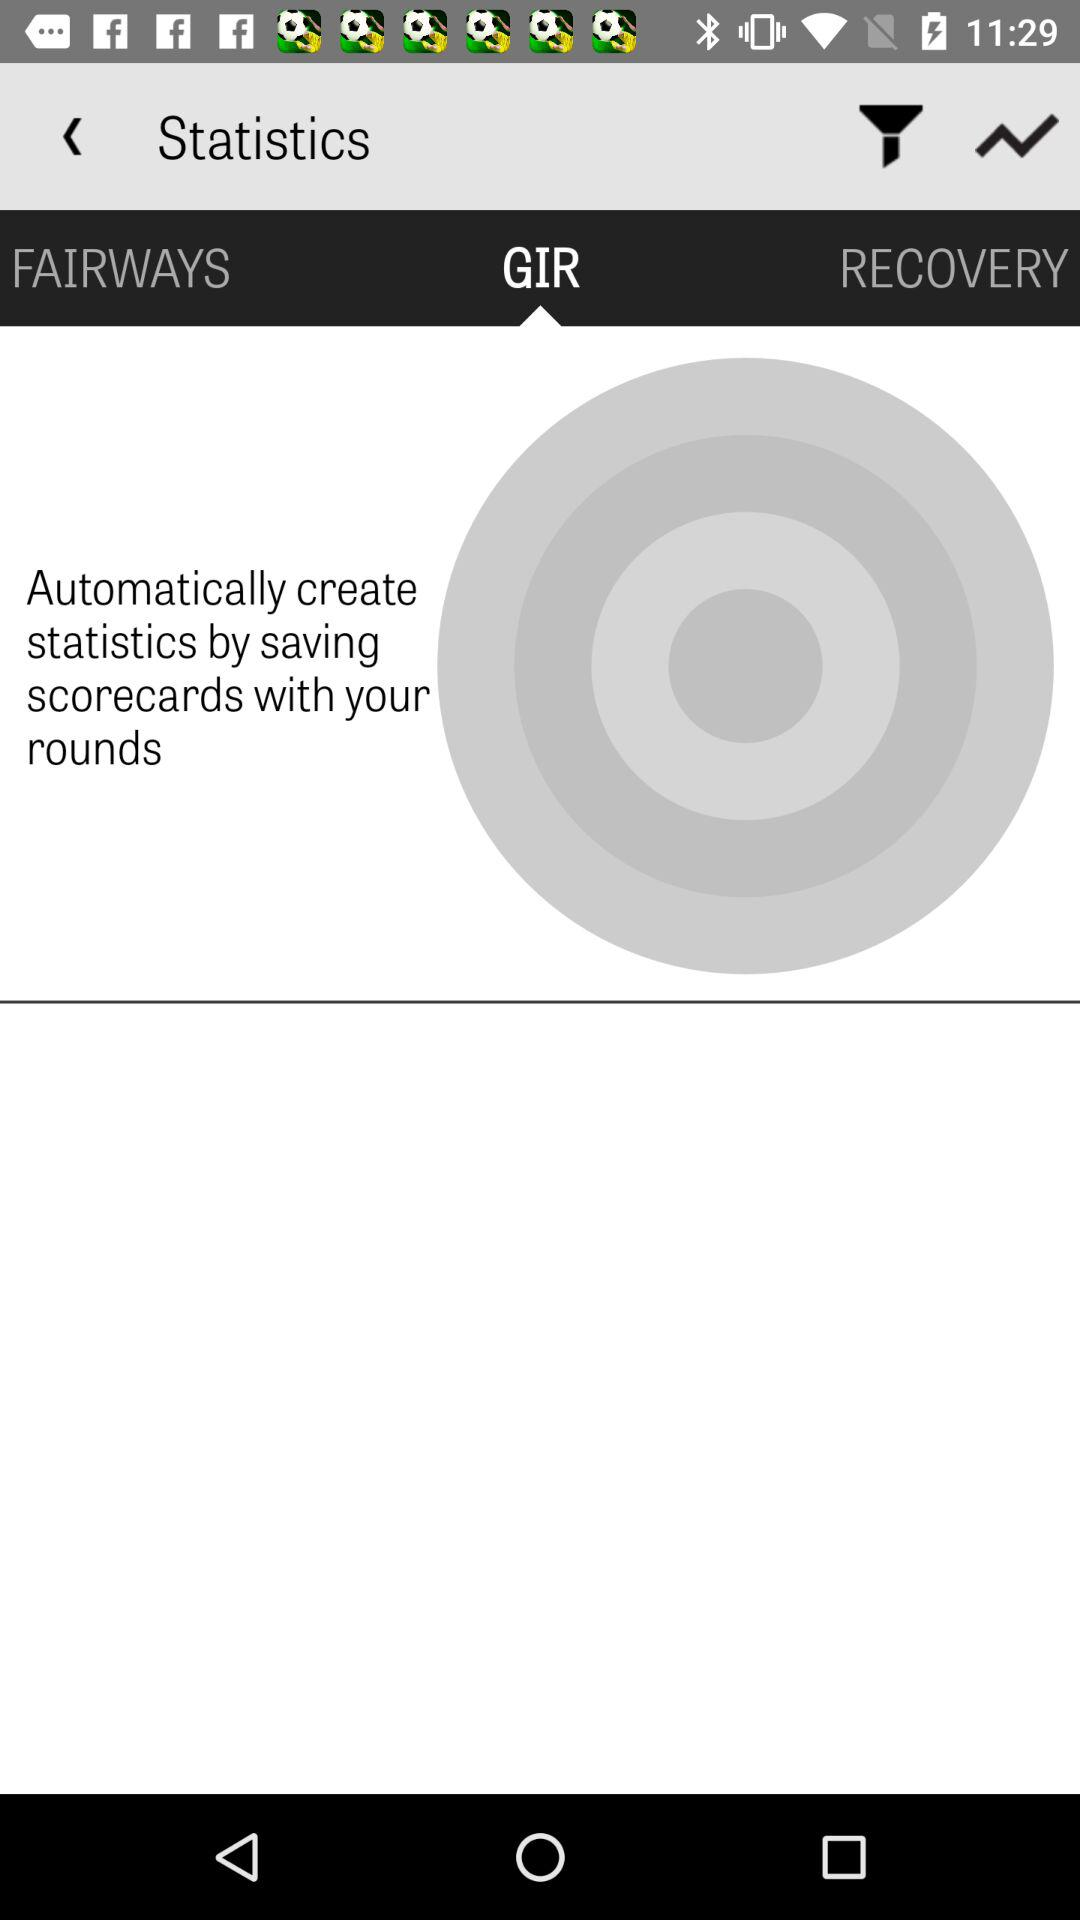What option is selected for the statistics? The selected option is GIR. 